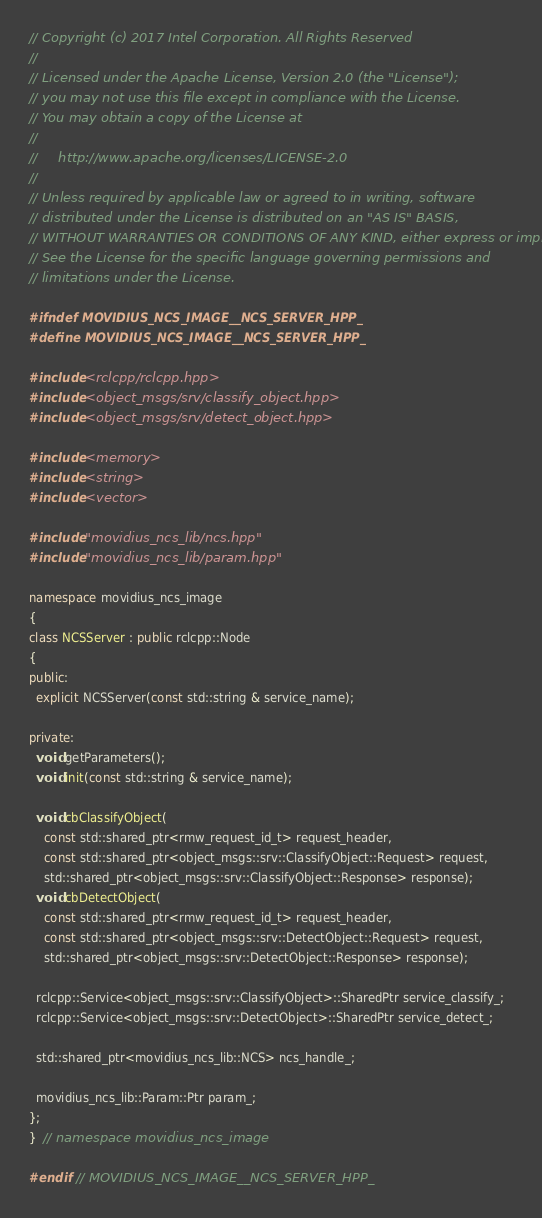<code> <loc_0><loc_0><loc_500><loc_500><_C++_>// Copyright (c) 2017 Intel Corporation. All Rights Reserved
//
// Licensed under the Apache License, Version 2.0 (the "License");
// you may not use this file except in compliance with the License.
// You may obtain a copy of the License at
//
//     http://www.apache.org/licenses/LICENSE-2.0
//
// Unless required by applicable law or agreed to in writing, software
// distributed under the License is distributed on an "AS IS" BASIS,
// WITHOUT WARRANTIES OR CONDITIONS OF ANY KIND, either express or implied.
// See the License for the specific language governing permissions and
// limitations under the License.

#ifndef MOVIDIUS_NCS_IMAGE__NCS_SERVER_HPP_
#define MOVIDIUS_NCS_IMAGE__NCS_SERVER_HPP_

#include <rclcpp/rclcpp.hpp>
#include <object_msgs/srv/classify_object.hpp>
#include <object_msgs/srv/detect_object.hpp>

#include <memory>
#include <string>
#include <vector>

#include "movidius_ncs_lib/ncs.hpp"
#include "movidius_ncs_lib/param.hpp"

namespace movidius_ncs_image
{
class NCSServer : public rclcpp::Node
{
public:
  explicit NCSServer(const std::string & service_name);

private:
  void getParameters();
  void init(const std::string & service_name);

  void cbClassifyObject(
    const std::shared_ptr<rmw_request_id_t> request_header,
    const std::shared_ptr<object_msgs::srv::ClassifyObject::Request> request,
    std::shared_ptr<object_msgs::srv::ClassifyObject::Response> response);
  void cbDetectObject(
    const std::shared_ptr<rmw_request_id_t> request_header,
    const std::shared_ptr<object_msgs::srv::DetectObject::Request> request,
    std::shared_ptr<object_msgs::srv::DetectObject::Response> response);

  rclcpp::Service<object_msgs::srv::ClassifyObject>::SharedPtr service_classify_;
  rclcpp::Service<object_msgs::srv::DetectObject>::SharedPtr service_detect_;

  std::shared_ptr<movidius_ncs_lib::NCS> ncs_handle_;

  movidius_ncs_lib::Param::Ptr param_;
};
}  // namespace movidius_ncs_image

#endif  // MOVIDIUS_NCS_IMAGE__NCS_SERVER_HPP_
</code> 